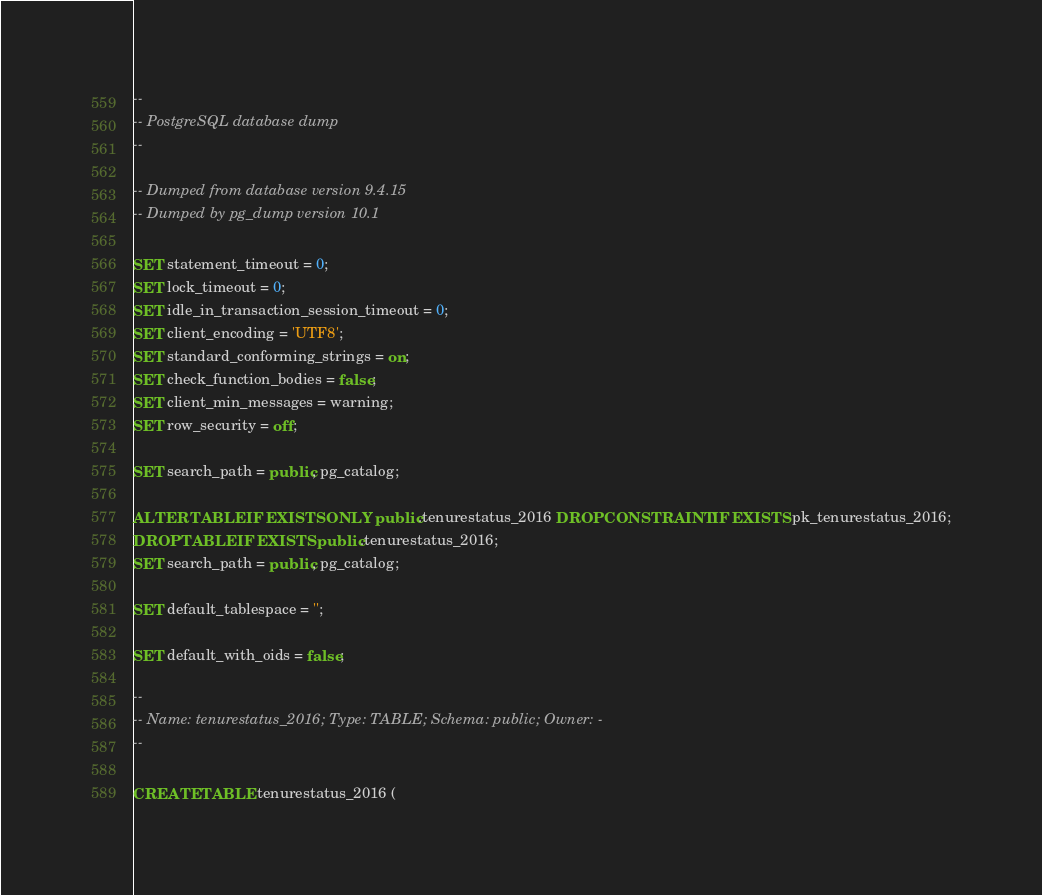<code> <loc_0><loc_0><loc_500><loc_500><_SQL_>--
-- PostgreSQL database dump
--

-- Dumped from database version 9.4.15
-- Dumped by pg_dump version 10.1

SET statement_timeout = 0;
SET lock_timeout = 0;
SET idle_in_transaction_session_timeout = 0;
SET client_encoding = 'UTF8';
SET standard_conforming_strings = on;
SET check_function_bodies = false;
SET client_min_messages = warning;
SET row_security = off;

SET search_path = public, pg_catalog;

ALTER TABLE IF EXISTS ONLY public.tenurestatus_2016 DROP CONSTRAINT IF EXISTS pk_tenurestatus_2016;
DROP TABLE IF EXISTS public.tenurestatus_2016;
SET search_path = public, pg_catalog;

SET default_tablespace = '';

SET default_with_oids = false;

--
-- Name: tenurestatus_2016; Type: TABLE; Schema: public; Owner: -
--

CREATE TABLE tenurestatus_2016 (</code> 